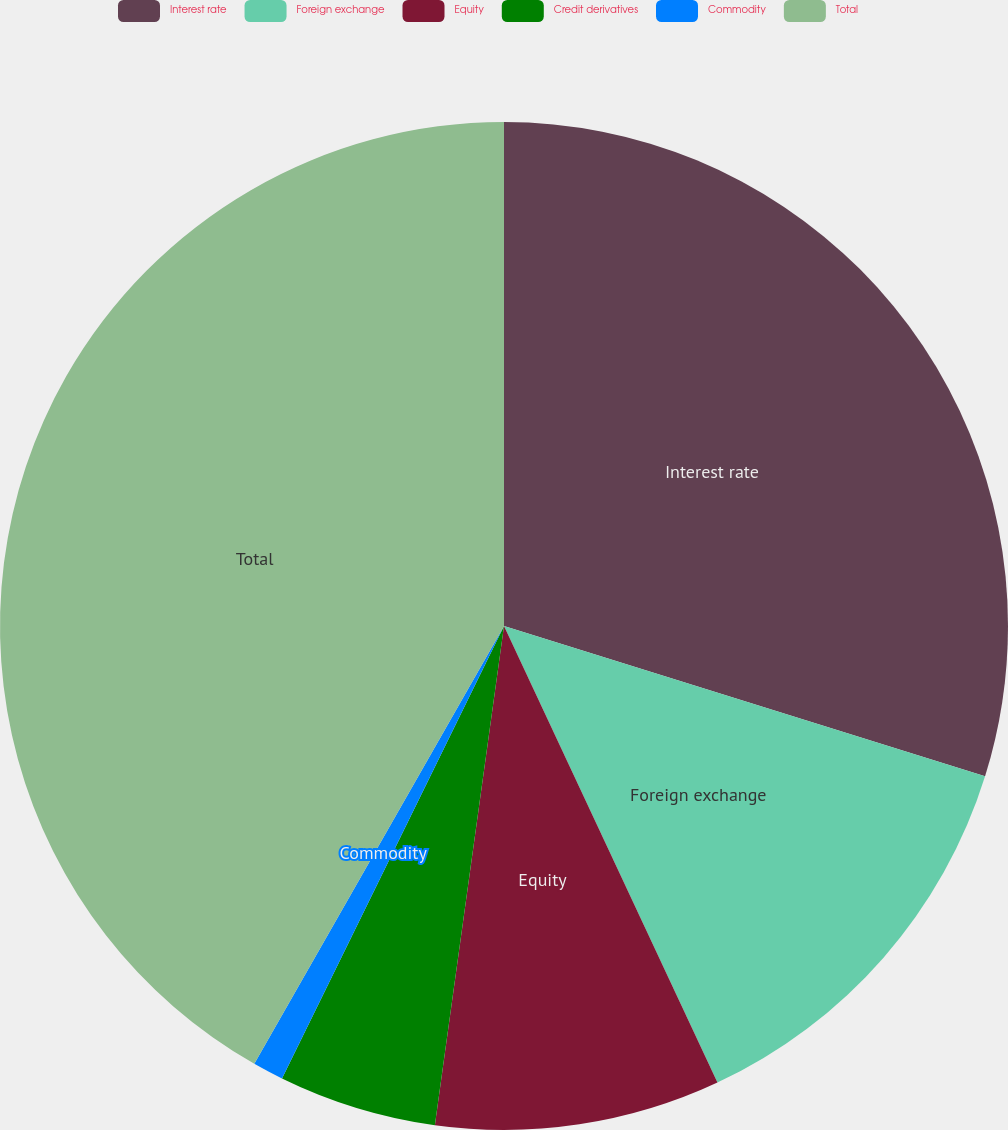<chart> <loc_0><loc_0><loc_500><loc_500><pie_chart><fcel>Interest rate<fcel>Foreign exchange<fcel>Equity<fcel>Credit derivatives<fcel>Commodity<fcel>Total<nl><fcel>29.82%<fcel>13.22%<fcel>9.15%<fcel>5.07%<fcel>0.99%<fcel>41.75%<nl></chart> 